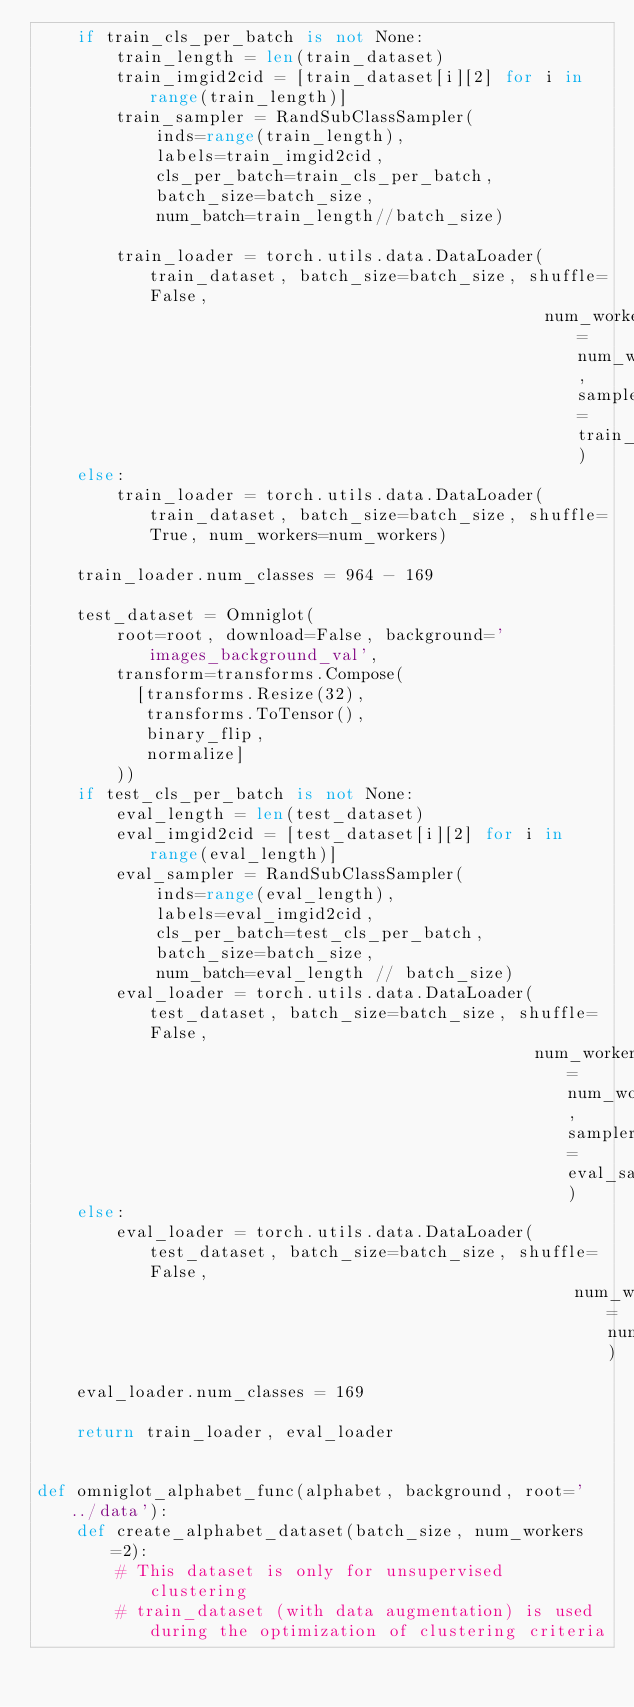Convert code to text. <code><loc_0><loc_0><loc_500><loc_500><_Python_>    if train_cls_per_batch is not None:
        train_length = len(train_dataset)
        train_imgid2cid = [train_dataset[i][2] for i in range(train_length)]  
        train_sampler = RandSubClassSampler(
            inds=range(train_length),
            labels=train_imgid2cid,
            cls_per_batch=train_cls_per_batch,
            batch_size=batch_size,
            num_batch=train_length//batch_size)

        train_loader = torch.utils.data.DataLoader(train_dataset, batch_size=batch_size, shuffle=False,
                                                   num_workers=num_workers, sampler=train_sampler)
    else:
        train_loader = torch.utils.data.DataLoader(train_dataset, batch_size=batch_size, shuffle=True, num_workers=num_workers)

    train_loader.num_classes = 964 - 169

    test_dataset = Omniglot(
        root=root, download=False, background='images_background_val',
        transform=transforms.Compose(
          [transforms.Resize(32),
           transforms.ToTensor(),
           binary_flip,
           normalize]
        ))
    if test_cls_per_batch is not None:
        eval_length = len(test_dataset)
        eval_imgid2cid = [test_dataset[i][2] for i in range(eval_length)]
        eval_sampler = RandSubClassSampler(
            inds=range(eval_length),
            labels=eval_imgid2cid,
            cls_per_batch=test_cls_per_batch,
            batch_size=batch_size,
            num_batch=eval_length // batch_size)
        eval_loader = torch.utils.data.DataLoader(test_dataset, batch_size=batch_size, shuffle=False,
                                                  num_workers=num_workers, sampler=eval_sampler)
    else:
        eval_loader = torch.utils.data.DataLoader(test_dataset, batch_size=batch_size, shuffle=False,
                                                      num_workers=num_workers)
    eval_loader.num_classes = 169 

    return train_loader, eval_loader


def omniglot_alphabet_func(alphabet, background, root='../data'):
    def create_alphabet_dataset(batch_size, num_workers=2):
        # This dataset is only for unsupervised clustering
        # train_dataset (with data augmentation) is used during the optimization of clustering criteria</code> 